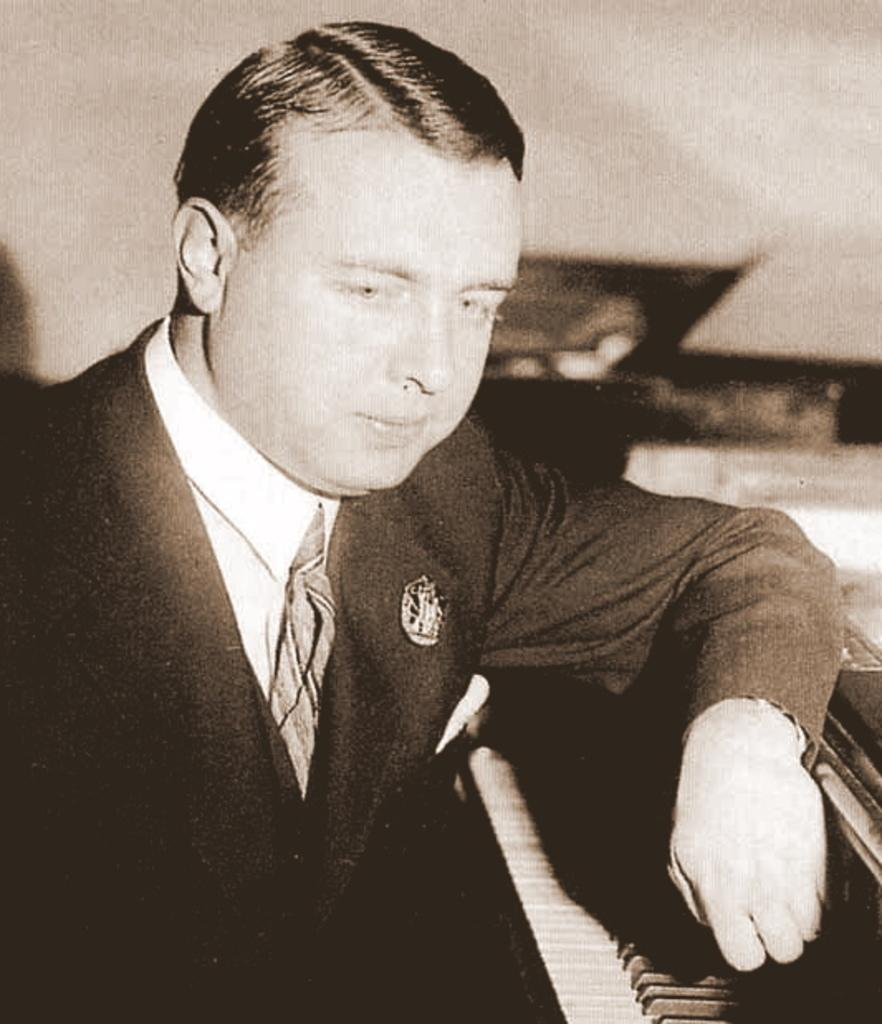Who is present in the image? There is a man in the image. What is the man wearing? The man is wearing a black suit. What object is the man standing in front of? The man is standing in front of a musical keyboard. What type of hospital equipment can be seen in the image? There is no hospital equipment present in the image; it features a man in a black suit standing in front of a musical keyboard. 